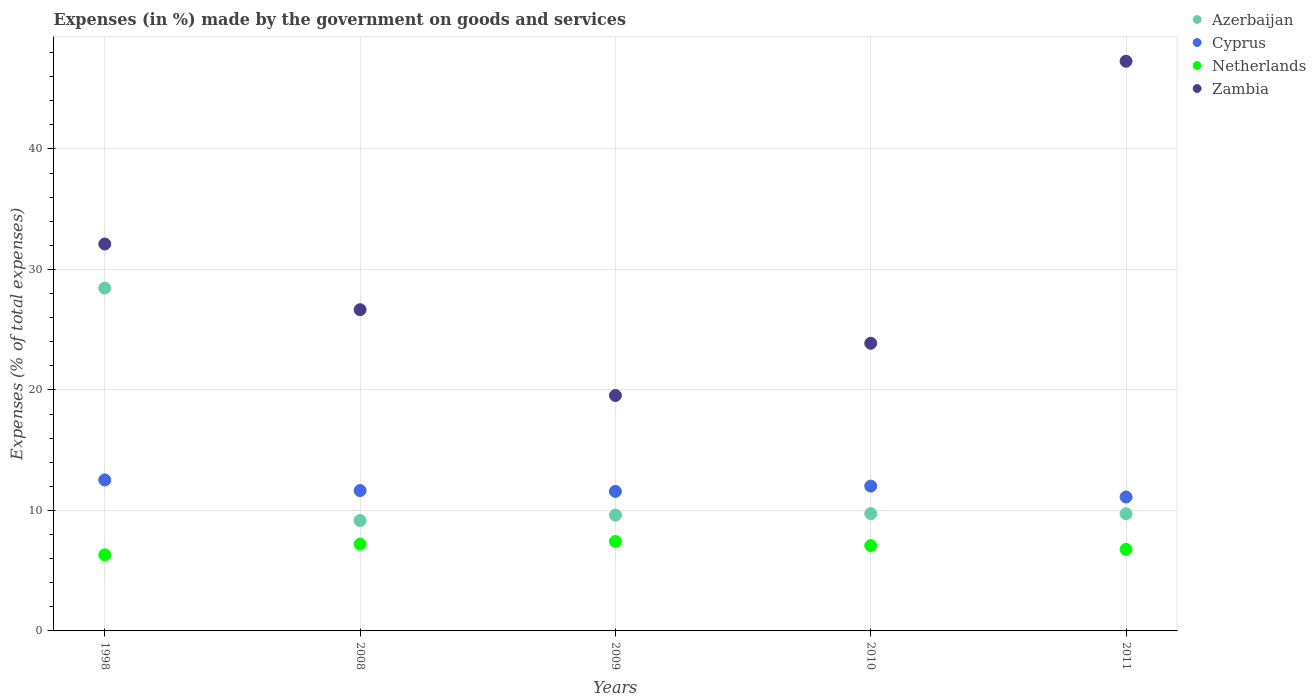Is the number of dotlines equal to the number of legend labels?
Ensure brevity in your answer.  Yes. What is the percentage of expenses made by the government on goods and services in Azerbaijan in 2011?
Keep it short and to the point. 9.73. Across all years, what is the maximum percentage of expenses made by the government on goods and services in Netherlands?
Ensure brevity in your answer.  7.43. Across all years, what is the minimum percentage of expenses made by the government on goods and services in Azerbaijan?
Provide a short and direct response. 9.16. In which year was the percentage of expenses made by the government on goods and services in Cyprus minimum?
Your response must be concise. 2011. What is the total percentage of expenses made by the government on goods and services in Azerbaijan in the graph?
Provide a succinct answer. 66.69. What is the difference between the percentage of expenses made by the government on goods and services in Azerbaijan in 1998 and that in 2009?
Your answer should be compact. 18.84. What is the difference between the percentage of expenses made by the government on goods and services in Zambia in 1998 and the percentage of expenses made by the government on goods and services in Azerbaijan in 2008?
Provide a short and direct response. 22.95. What is the average percentage of expenses made by the government on goods and services in Netherlands per year?
Your answer should be very brief. 6.96. In the year 2009, what is the difference between the percentage of expenses made by the government on goods and services in Azerbaijan and percentage of expenses made by the government on goods and services in Cyprus?
Provide a short and direct response. -1.97. In how many years, is the percentage of expenses made by the government on goods and services in Netherlands greater than 4 %?
Your response must be concise. 5. What is the ratio of the percentage of expenses made by the government on goods and services in Cyprus in 2009 to that in 2010?
Give a very brief answer. 0.96. Is the percentage of expenses made by the government on goods and services in Cyprus in 1998 less than that in 2009?
Offer a very short reply. No. Is the difference between the percentage of expenses made by the government on goods and services in Azerbaijan in 2009 and 2011 greater than the difference between the percentage of expenses made by the government on goods and services in Cyprus in 2009 and 2011?
Your response must be concise. No. What is the difference between the highest and the second highest percentage of expenses made by the government on goods and services in Netherlands?
Your response must be concise. 0.23. What is the difference between the highest and the lowest percentage of expenses made by the government on goods and services in Netherlands?
Offer a terse response. 1.11. In how many years, is the percentage of expenses made by the government on goods and services in Netherlands greater than the average percentage of expenses made by the government on goods and services in Netherlands taken over all years?
Your answer should be very brief. 3. Is it the case that in every year, the sum of the percentage of expenses made by the government on goods and services in Zambia and percentage of expenses made by the government on goods and services in Netherlands  is greater than the sum of percentage of expenses made by the government on goods and services in Cyprus and percentage of expenses made by the government on goods and services in Azerbaijan?
Offer a terse response. Yes. Does the percentage of expenses made by the government on goods and services in Azerbaijan monotonically increase over the years?
Provide a succinct answer. No. Is the percentage of expenses made by the government on goods and services in Zambia strictly greater than the percentage of expenses made by the government on goods and services in Netherlands over the years?
Make the answer very short. Yes. Is the percentage of expenses made by the government on goods and services in Cyprus strictly less than the percentage of expenses made by the government on goods and services in Netherlands over the years?
Ensure brevity in your answer.  No. How many years are there in the graph?
Provide a short and direct response. 5. Are the values on the major ticks of Y-axis written in scientific E-notation?
Make the answer very short. No. Does the graph contain any zero values?
Make the answer very short. No. Does the graph contain grids?
Offer a terse response. Yes. How are the legend labels stacked?
Your answer should be very brief. Vertical. What is the title of the graph?
Give a very brief answer. Expenses (in %) made by the government on goods and services. Does "Myanmar" appear as one of the legend labels in the graph?
Provide a succinct answer. No. What is the label or title of the Y-axis?
Provide a succinct answer. Expenses (% of total expenses). What is the Expenses (% of total expenses) in Azerbaijan in 1998?
Make the answer very short. 28.45. What is the Expenses (% of total expenses) in Cyprus in 1998?
Your answer should be very brief. 12.53. What is the Expenses (% of total expenses) in Netherlands in 1998?
Your response must be concise. 6.32. What is the Expenses (% of total expenses) of Zambia in 1998?
Your answer should be compact. 32.11. What is the Expenses (% of total expenses) in Azerbaijan in 2008?
Your answer should be compact. 9.16. What is the Expenses (% of total expenses) in Cyprus in 2008?
Make the answer very short. 11.65. What is the Expenses (% of total expenses) in Netherlands in 2008?
Ensure brevity in your answer.  7.2. What is the Expenses (% of total expenses) in Zambia in 2008?
Your response must be concise. 26.66. What is the Expenses (% of total expenses) of Azerbaijan in 2009?
Your response must be concise. 9.61. What is the Expenses (% of total expenses) of Cyprus in 2009?
Make the answer very short. 11.58. What is the Expenses (% of total expenses) of Netherlands in 2009?
Your answer should be very brief. 7.43. What is the Expenses (% of total expenses) in Zambia in 2009?
Provide a succinct answer. 19.54. What is the Expenses (% of total expenses) in Azerbaijan in 2010?
Keep it short and to the point. 9.74. What is the Expenses (% of total expenses) of Cyprus in 2010?
Ensure brevity in your answer.  12.02. What is the Expenses (% of total expenses) of Netherlands in 2010?
Your response must be concise. 7.08. What is the Expenses (% of total expenses) in Zambia in 2010?
Provide a short and direct response. 23.87. What is the Expenses (% of total expenses) of Azerbaijan in 2011?
Provide a succinct answer. 9.73. What is the Expenses (% of total expenses) of Cyprus in 2011?
Give a very brief answer. 11.11. What is the Expenses (% of total expenses) in Netherlands in 2011?
Give a very brief answer. 6.77. What is the Expenses (% of total expenses) in Zambia in 2011?
Make the answer very short. 47.28. Across all years, what is the maximum Expenses (% of total expenses) of Azerbaijan?
Keep it short and to the point. 28.45. Across all years, what is the maximum Expenses (% of total expenses) in Cyprus?
Provide a succinct answer. 12.53. Across all years, what is the maximum Expenses (% of total expenses) of Netherlands?
Offer a very short reply. 7.43. Across all years, what is the maximum Expenses (% of total expenses) in Zambia?
Offer a very short reply. 47.28. Across all years, what is the minimum Expenses (% of total expenses) in Azerbaijan?
Offer a very short reply. 9.16. Across all years, what is the minimum Expenses (% of total expenses) in Cyprus?
Your answer should be very brief. 11.11. Across all years, what is the minimum Expenses (% of total expenses) of Netherlands?
Offer a very short reply. 6.32. Across all years, what is the minimum Expenses (% of total expenses) of Zambia?
Provide a succinct answer. 19.54. What is the total Expenses (% of total expenses) of Azerbaijan in the graph?
Provide a succinct answer. 66.69. What is the total Expenses (% of total expenses) in Cyprus in the graph?
Your answer should be compact. 58.89. What is the total Expenses (% of total expenses) of Netherlands in the graph?
Give a very brief answer. 34.79. What is the total Expenses (% of total expenses) of Zambia in the graph?
Ensure brevity in your answer.  149.46. What is the difference between the Expenses (% of total expenses) of Azerbaijan in 1998 and that in 2008?
Keep it short and to the point. 19.29. What is the difference between the Expenses (% of total expenses) in Cyprus in 1998 and that in 2008?
Give a very brief answer. 0.88. What is the difference between the Expenses (% of total expenses) of Netherlands in 1998 and that in 2008?
Your answer should be compact. -0.88. What is the difference between the Expenses (% of total expenses) of Zambia in 1998 and that in 2008?
Make the answer very short. 5.45. What is the difference between the Expenses (% of total expenses) in Azerbaijan in 1998 and that in 2009?
Make the answer very short. 18.84. What is the difference between the Expenses (% of total expenses) of Cyprus in 1998 and that in 2009?
Provide a short and direct response. 0.95. What is the difference between the Expenses (% of total expenses) in Netherlands in 1998 and that in 2009?
Offer a very short reply. -1.11. What is the difference between the Expenses (% of total expenses) of Zambia in 1998 and that in 2009?
Keep it short and to the point. 12.57. What is the difference between the Expenses (% of total expenses) of Azerbaijan in 1998 and that in 2010?
Ensure brevity in your answer.  18.71. What is the difference between the Expenses (% of total expenses) in Cyprus in 1998 and that in 2010?
Ensure brevity in your answer.  0.51. What is the difference between the Expenses (% of total expenses) of Netherlands in 1998 and that in 2010?
Your answer should be very brief. -0.77. What is the difference between the Expenses (% of total expenses) of Zambia in 1998 and that in 2010?
Offer a terse response. 8.24. What is the difference between the Expenses (% of total expenses) in Azerbaijan in 1998 and that in 2011?
Ensure brevity in your answer.  18.72. What is the difference between the Expenses (% of total expenses) of Cyprus in 1998 and that in 2011?
Offer a very short reply. 1.42. What is the difference between the Expenses (% of total expenses) in Netherlands in 1998 and that in 2011?
Your answer should be very brief. -0.45. What is the difference between the Expenses (% of total expenses) in Zambia in 1998 and that in 2011?
Your response must be concise. -15.17. What is the difference between the Expenses (% of total expenses) in Azerbaijan in 2008 and that in 2009?
Provide a short and direct response. -0.45. What is the difference between the Expenses (% of total expenses) of Cyprus in 2008 and that in 2009?
Offer a terse response. 0.07. What is the difference between the Expenses (% of total expenses) of Netherlands in 2008 and that in 2009?
Ensure brevity in your answer.  -0.23. What is the difference between the Expenses (% of total expenses) in Zambia in 2008 and that in 2009?
Your answer should be compact. 7.12. What is the difference between the Expenses (% of total expenses) of Azerbaijan in 2008 and that in 2010?
Make the answer very short. -0.58. What is the difference between the Expenses (% of total expenses) of Cyprus in 2008 and that in 2010?
Keep it short and to the point. -0.37. What is the difference between the Expenses (% of total expenses) of Netherlands in 2008 and that in 2010?
Keep it short and to the point. 0.12. What is the difference between the Expenses (% of total expenses) in Zambia in 2008 and that in 2010?
Your response must be concise. 2.79. What is the difference between the Expenses (% of total expenses) in Azerbaijan in 2008 and that in 2011?
Your answer should be very brief. -0.57. What is the difference between the Expenses (% of total expenses) in Cyprus in 2008 and that in 2011?
Make the answer very short. 0.53. What is the difference between the Expenses (% of total expenses) in Netherlands in 2008 and that in 2011?
Your answer should be compact. 0.43. What is the difference between the Expenses (% of total expenses) of Zambia in 2008 and that in 2011?
Ensure brevity in your answer.  -20.62. What is the difference between the Expenses (% of total expenses) of Azerbaijan in 2009 and that in 2010?
Provide a succinct answer. -0.13. What is the difference between the Expenses (% of total expenses) of Cyprus in 2009 and that in 2010?
Ensure brevity in your answer.  -0.44. What is the difference between the Expenses (% of total expenses) of Netherlands in 2009 and that in 2010?
Your answer should be compact. 0.34. What is the difference between the Expenses (% of total expenses) of Zambia in 2009 and that in 2010?
Make the answer very short. -4.34. What is the difference between the Expenses (% of total expenses) in Azerbaijan in 2009 and that in 2011?
Provide a short and direct response. -0.11. What is the difference between the Expenses (% of total expenses) in Cyprus in 2009 and that in 2011?
Offer a terse response. 0.47. What is the difference between the Expenses (% of total expenses) of Netherlands in 2009 and that in 2011?
Your response must be concise. 0.66. What is the difference between the Expenses (% of total expenses) in Zambia in 2009 and that in 2011?
Your answer should be compact. -27.74. What is the difference between the Expenses (% of total expenses) in Azerbaijan in 2010 and that in 2011?
Offer a very short reply. 0.01. What is the difference between the Expenses (% of total expenses) of Cyprus in 2010 and that in 2011?
Provide a succinct answer. 0.91. What is the difference between the Expenses (% of total expenses) in Netherlands in 2010 and that in 2011?
Provide a short and direct response. 0.31. What is the difference between the Expenses (% of total expenses) of Zambia in 2010 and that in 2011?
Make the answer very short. -23.41. What is the difference between the Expenses (% of total expenses) in Azerbaijan in 1998 and the Expenses (% of total expenses) in Cyprus in 2008?
Your answer should be very brief. 16.8. What is the difference between the Expenses (% of total expenses) in Azerbaijan in 1998 and the Expenses (% of total expenses) in Netherlands in 2008?
Keep it short and to the point. 21.25. What is the difference between the Expenses (% of total expenses) in Azerbaijan in 1998 and the Expenses (% of total expenses) in Zambia in 2008?
Ensure brevity in your answer.  1.79. What is the difference between the Expenses (% of total expenses) in Cyprus in 1998 and the Expenses (% of total expenses) in Netherlands in 2008?
Make the answer very short. 5.33. What is the difference between the Expenses (% of total expenses) in Cyprus in 1998 and the Expenses (% of total expenses) in Zambia in 2008?
Provide a succinct answer. -14.13. What is the difference between the Expenses (% of total expenses) of Netherlands in 1998 and the Expenses (% of total expenses) of Zambia in 2008?
Ensure brevity in your answer.  -20.34. What is the difference between the Expenses (% of total expenses) in Azerbaijan in 1998 and the Expenses (% of total expenses) in Cyprus in 2009?
Offer a very short reply. 16.87. What is the difference between the Expenses (% of total expenses) of Azerbaijan in 1998 and the Expenses (% of total expenses) of Netherlands in 2009?
Your answer should be very brief. 21.02. What is the difference between the Expenses (% of total expenses) in Azerbaijan in 1998 and the Expenses (% of total expenses) in Zambia in 2009?
Offer a very short reply. 8.91. What is the difference between the Expenses (% of total expenses) in Cyprus in 1998 and the Expenses (% of total expenses) in Netherlands in 2009?
Provide a succinct answer. 5.1. What is the difference between the Expenses (% of total expenses) in Cyprus in 1998 and the Expenses (% of total expenses) in Zambia in 2009?
Make the answer very short. -7.01. What is the difference between the Expenses (% of total expenses) in Netherlands in 1998 and the Expenses (% of total expenses) in Zambia in 2009?
Your answer should be compact. -13.22. What is the difference between the Expenses (% of total expenses) in Azerbaijan in 1998 and the Expenses (% of total expenses) in Cyprus in 2010?
Make the answer very short. 16.43. What is the difference between the Expenses (% of total expenses) in Azerbaijan in 1998 and the Expenses (% of total expenses) in Netherlands in 2010?
Your response must be concise. 21.37. What is the difference between the Expenses (% of total expenses) of Azerbaijan in 1998 and the Expenses (% of total expenses) of Zambia in 2010?
Your response must be concise. 4.58. What is the difference between the Expenses (% of total expenses) in Cyprus in 1998 and the Expenses (% of total expenses) in Netherlands in 2010?
Your answer should be compact. 5.45. What is the difference between the Expenses (% of total expenses) of Cyprus in 1998 and the Expenses (% of total expenses) of Zambia in 2010?
Provide a succinct answer. -11.34. What is the difference between the Expenses (% of total expenses) in Netherlands in 1998 and the Expenses (% of total expenses) in Zambia in 2010?
Give a very brief answer. -17.56. What is the difference between the Expenses (% of total expenses) of Azerbaijan in 1998 and the Expenses (% of total expenses) of Cyprus in 2011?
Keep it short and to the point. 17.33. What is the difference between the Expenses (% of total expenses) in Azerbaijan in 1998 and the Expenses (% of total expenses) in Netherlands in 2011?
Provide a succinct answer. 21.68. What is the difference between the Expenses (% of total expenses) in Azerbaijan in 1998 and the Expenses (% of total expenses) in Zambia in 2011?
Offer a very short reply. -18.83. What is the difference between the Expenses (% of total expenses) of Cyprus in 1998 and the Expenses (% of total expenses) of Netherlands in 2011?
Ensure brevity in your answer.  5.76. What is the difference between the Expenses (% of total expenses) of Cyprus in 1998 and the Expenses (% of total expenses) of Zambia in 2011?
Provide a succinct answer. -34.75. What is the difference between the Expenses (% of total expenses) of Netherlands in 1998 and the Expenses (% of total expenses) of Zambia in 2011?
Make the answer very short. -40.96. What is the difference between the Expenses (% of total expenses) of Azerbaijan in 2008 and the Expenses (% of total expenses) of Cyprus in 2009?
Make the answer very short. -2.42. What is the difference between the Expenses (% of total expenses) of Azerbaijan in 2008 and the Expenses (% of total expenses) of Netherlands in 2009?
Provide a succinct answer. 1.73. What is the difference between the Expenses (% of total expenses) of Azerbaijan in 2008 and the Expenses (% of total expenses) of Zambia in 2009?
Your answer should be very brief. -10.38. What is the difference between the Expenses (% of total expenses) in Cyprus in 2008 and the Expenses (% of total expenses) in Netherlands in 2009?
Provide a short and direct response. 4.22. What is the difference between the Expenses (% of total expenses) of Cyprus in 2008 and the Expenses (% of total expenses) of Zambia in 2009?
Give a very brief answer. -7.89. What is the difference between the Expenses (% of total expenses) of Netherlands in 2008 and the Expenses (% of total expenses) of Zambia in 2009?
Offer a terse response. -12.34. What is the difference between the Expenses (% of total expenses) in Azerbaijan in 2008 and the Expenses (% of total expenses) in Cyprus in 2010?
Your response must be concise. -2.86. What is the difference between the Expenses (% of total expenses) of Azerbaijan in 2008 and the Expenses (% of total expenses) of Netherlands in 2010?
Provide a short and direct response. 2.08. What is the difference between the Expenses (% of total expenses) in Azerbaijan in 2008 and the Expenses (% of total expenses) in Zambia in 2010?
Offer a very short reply. -14.71. What is the difference between the Expenses (% of total expenses) of Cyprus in 2008 and the Expenses (% of total expenses) of Netherlands in 2010?
Your answer should be very brief. 4.57. What is the difference between the Expenses (% of total expenses) in Cyprus in 2008 and the Expenses (% of total expenses) in Zambia in 2010?
Give a very brief answer. -12.23. What is the difference between the Expenses (% of total expenses) in Netherlands in 2008 and the Expenses (% of total expenses) in Zambia in 2010?
Offer a terse response. -16.67. What is the difference between the Expenses (% of total expenses) in Azerbaijan in 2008 and the Expenses (% of total expenses) in Cyprus in 2011?
Provide a succinct answer. -1.95. What is the difference between the Expenses (% of total expenses) of Azerbaijan in 2008 and the Expenses (% of total expenses) of Netherlands in 2011?
Provide a succinct answer. 2.39. What is the difference between the Expenses (% of total expenses) of Azerbaijan in 2008 and the Expenses (% of total expenses) of Zambia in 2011?
Your answer should be compact. -38.12. What is the difference between the Expenses (% of total expenses) of Cyprus in 2008 and the Expenses (% of total expenses) of Netherlands in 2011?
Give a very brief answer. 4.88. What is the difference between the Expenses (% of total expenses) of Cyprus in 2008 and the Expenses (% of total expenses) of Zambia in 2011?
Provide a succinct answer. -35.63. What is the difference between the Expenses (% of total expenses) in Netherlands in 2008 and the Expenses (% of total expenses) in Zambia in 2011?
Your answer should be compact. -40.08. What is the difference between the Expenses (% of total expenses) in Azerbaijan in 2009 and the Expenses (% of total expenses) in Cyprus in 2010?
Your answer should be compact. -2.41. What is the difference between the Expenses (% of total expenses) in Azerbaijan in 2009 and the Expenses (% of total expenses) in Netherlands in 2010?
Offer a very short reply. 2.53. What is the difference between the Expenses (% of total expenses) of Azerbaijan in 2009 and the Expenses (% of total expenses) of Zambia in 2010?
Keep it short and to the point. -14.26. What is the difference between the Expenses (% of total expenses) of Cyprus in 2009 and the Expenses (% of total expenses) of Netherlands in 2010?
Provide a succinct answer. 4.5. What is the difference between the Expenses (% of total expenses) of Cyprus in 2009 and the Expenses (% of total expenses) of Zambia in 2010?
Offer a terse response. -12.29. What is the difference between the Expenses (% of total expenses) in Netherlands in 2009 and the Expenses (% of total expenses) in Zambia in 2010?
Give a very brief answer. -16.45. What is the difference between the Expenses (% of total expenses) in Azerbaijan in 2009 and the Expenses (% of total expenses) in Cyprus in 2011?
Make the answer very short. -1.5. What is the difference between the Expenses (% of total expenses) in Azerbaijan in 2009 and the Expenses (% of total expenses) in Netherlands in 2011?
Ensure brevity in your answer.  2.84. What is the difference between the Expenses (% of total expenses) in Azerbaijan in 2009 and the Expenses (% of total expenses) in Zambia in 2011?
Offer a terse response. -37.67. What is the difference between the Expenses (% of total expenses) in Cyprus in 2009 and the Expenses (% of total expenses) in Netherlands in 2011?
Your answer should be very brief. 4.81. What is the difference between the Expenses (% of total expenses) of Cyprus in 2009 and the Expenses (% of total expenses) of Zambia in 2011?
Ensure brevity in your answer.  -35.7. What is the difference between the Expenses (% of total expenses) of Netherlands in 2009 and the Expenses (% of total expenses) of Zambia in 2011?
Ensure brevity in your answer.  -39.85. What is the difference between the Expenses (% of total expenses) in Azerbaijan in 2010 and the Expenses (% of total expenses) in Cyprus in 2011?
Provide a short and direct response. -1.38. What is the difference between the Expenses (% of total expenses) of Azerbaijan in 2010 and the Expenses (% of total expenses) of Netherlands in 2011?
Offer a very short reply. 2.97. What is the difference between the Expenses (% of total expenses) in Azerbaijan in 2010 and the Expenses (% of total expenses) in Zambia in 2011?
Provide a succinct answer. -37.54. What is the difference between the Expenses (% of total expenses) in Cyprus in 2010 and the Expenses (% of total expenses) in Netherlands in 2011?
Your response must be concise. 5.25. What is the difference between the Expenses (% of total expenses) in Cyprus in 2010 and the Expenses (% of total expenses) in Zambia in 2011?
Keep it short and to the point. -35.26. What is the difference between the Expenses (% of total expenses) in Netherlands in 2010 and the Expenses (% of total expenses) in Zambia in 2011?
Keep it short and to the point. -40.2. What is the average Expenses (% of total expenses) in Azerbaijan per year?
Your answer should be compact. 13.34. What is the average Expenses (% of total expenses) in Cyprus per year?
Your response must be concise. 11.78. What is the average Expenses (% of total expenses) in Netherlands per year?
Provide a short and direct response. 6.96. What is the average Expenses (% of total expenses) of Zambia per year?
Keep it short and to the point. 29.89. In the year 1998, what is the difference between the Expenses (% of total expenses) of Azerbaijan and Expenses (% of total expenses) of Cyprus?
Ensure brevity in your answer.  15.92. In the year 1998, what is the difference between the Expenses (% of total expenses) of Azerbaijan and Expenses (% of total expenses) of Netherlands?
Offer a very short reply. 22.13. In the year 1998, what is the difference between the Expenses (% of total expenses) in Azerbaijan and Expenses (% of total expenses) in Zambia?
Give a very brief answer. -3.66. In the year 1998, what is the difference between the Expenses (% of total expenses) in Cyprus and Expenses (% of total expenses) in Netherlands?
Provide a short and direct response. 6.21. In the year 1998, what is the difference between the Expenses (% of total expenses) of Cyprus and Expenses (% of total expenses) of Zambia?
Your answer should be very brief. -19.58. In the year 1998, what is the difference between the Expenses (% of total expenses) of Netherlands and Expenses (% of total expenses) of Zambia?
Your response must be concise. -25.79. In the year 2008, what is the difference between the Expenses (% of total expenses) in Azerbaijan and Expenses (% of total expenses) in Cyprus?
Offer a terse response. -2.49. In the year 2008, what is the difference between the Expenses (% of total expenses) in Azerbaijan and Expenses (% of total expenses) in Netherlands?
Give a very brief answer. 1.96. In the year 2008, what is the difference between the Expenses (% of total expenses) of Azerbaijan and Expenses (% of total expenses) of Zambia?
Your response must be concise. -17.5. In the year 2008, what is the difference between the Expenses (% of total expenses) in Cyprus and Expenses (% of total expenses) in Netherlands?
Ensure brevity in your answer.  4.45. In the year 2008, what is the difference between the Expenses (% of total expenses) in Cyprus and Expenses (% of total expenses) in Zambia?
Give a very brief answer. -15.01. In the year 2008, what is the difference between the Expenses (% of total expenses) in Netherlands and Expenses (% of total expenses) in Zambia?
Your answer should be very brief. -19.46. In the year 2009, what is the difference between the Expenses (% of total expenses) in Azerbaijan and Expenses (% of total expenses) in Cyprus?
Your answer should be compact. -1.97. In the year 2009, what is the difference between the Expenses (% of total expenses) in Azerbaijan and Expenses (% of total expenses) in Netherlands?
Offer a terse response. 2.19. In the year 2009, what is the difference between the Expenses (% of total expenses) of Azerbaijan and Expenses (% of total expenses) of Zambia?
Provide a succinct answer. -9.93. In the year 2009, what is the difference between the Expenses (% of total expenses) in Cyprus and Expenses (% of total expenses) in Netherlands?
Provide a short and direct response. 4.15. In the year 2009, what is the difference between the Expenses (% of total expenses) of Cyprus and Expenses (% of total expenses) of Zambia?
Ensure brevity in your answer.  -7.96. In the year 2009, what is the difference between the Expenses (% of total expenses) of Netherlands and Expenses (% of total expenses) of Zambia?
Offer a terse response. -12.11. In the year 2010, what is the difference between the Expenses (% of total expenses) in Azerbaijan and Expenses (% of total expenses) in Cyprus?
Your response must be concise. -2.28. In the year 2010, what is the difference between the Expenses (% of total expenses) in Azerbaijan and Expenses (% of total expenses) in Netherlands?
Make the answer very short. 2.66. In the year 2010, what is the difference between the Expenses (% of total expenses) in Azerbaijan and Expenses (% of total expenses) in Zambia?
Keep it short and to the point. -14.13. In the year 2010, what is the difference between the Expenses (% of total expenses) of Cyprus and Expenses (% of total expenses) of Netherlands?
Offer a very short reply. 4.94. In the year 2010, what is the difference between the Expenses (% of total expenses) in Cyprus and Expenses (% of total expenses) in Zambia?
Provide a short and direct response. -11.85. In the year 2010, what is the difference between the Expenses (% of total expenses) of Netherlands and Expenses (% of total expenses) of Zambia?
Provide a succinct answer. -16.79. In the year 2011, what is the difference between the Expenses (% of total expenses) in Azerbaijan and Expenses (% of total expenses) in Cyprus?
Your answer should be very brief. -1.39. In the year 2011, what is the difference between the Expenses (% of total expenses) in Azerbaijan and Expenses (% of total expenses) in Netherlands?
Provide a succinct answer. 2.96. In the year 2011, what is the difference between the Expenses (% of total expenses) in Azerbaijan and Expenses (% of total expenses) in Zambia?
Your response must be concise. -37.55. In the year 2011, what is the difference between the Expenses (% of total expenses) in Cyprus and Expenses (% of total expenses) in Netherlands?
Provide a succinct answer. 4.34. In the year 2011, what is the difference between the Expenses (% of total expenses) of Cyprus and Expenses (% of total expenses) of Zambia?
Provide a short and direct response. -36.16. In the year 2011, what is the difference between the Expenses (% of total expenses) of Netherlands and Expenses (% of total expenses) of Zambia?
Provide a short and direct response. -40.51. What is the ratio of the Expenses (% of total expenses) in Azerbaijan in 1998 to that in 2008?
Ensure brevity in your answer.  3.11. What is the ratio of the Expenses (% of total expenses) in Cyprus in 1998 to that in 2008?
Make the answer very short. 1.08. What is the ratio of the Expenses (% of total expenses) of Netherlands in 1998 to that in 2008?
Your response must be concise. 0.88. What is the ratio of the Expenses (% of total expenses) of Zambia in 1998 to that in 2008?
Offer a terse response. 1.2. What is the ratio of the Expenses (% of total expenses) of Azerbaijan in 1998 to that in 2009?
Your answer should be very brief. 2.96. What is the ratio of the Expenses (% of total expenses) of Cyprus in 1998 to that in 2009?
Your response must be concise. 1.08. What is the ratio of the Expenses (% of total expenses) in Netherlands in 1998 to that in 2009?
Your answer should be very brief. 0.85. What is the ratio of the Expenses (% of total expenses) in Zambia in 1998 to that in 2009?
Make the answer very short. 1.64. What is the ratio of the Expenses (% of total expenses) in Azerbaijan in 1998 to that in 2010?
Offer a very short reply. 2.92. What is the ratio of the Expenses (% of total expenses) of Cyprus in 1998 to that in 2010?
Your answer should be very brief. 1.04. What is the ratio of the Expenses (% of total expenses) of Netherlands in 1998 to that in 2010?
Provide a short and direct response. 0.89. What is the ratio of the Expenses (% of total expenses) in Zambia in 1998 to that in 2010?
Provide a succinct answer. 1.34. What is the ratio of the Expenses (% of total expenses) in Azerbaijan in 1998 to that in 2011?
Provide a short and direct response. 2.92. What is the ratio of the Expenses (% of total expenses) in Cyprus in 1998 to that in 2011?
Provide a short and direct response. 1.13. What is the ratio of the Expenses (% of total expenses) of Netherlands in 1998 to that in 2011?
Make the answer very short. 0.93. What is the ratio of the Expenses (% of total expenses) of Zambia in 1998 to that in 2011?
Your answer should be very brief. 0.68. What is the ratio of the Expenses (% of total expenses) in Azerbaijan in 2008 to that in 2009?
Offer a very short reply. 0.95. What is the ratio of the Expenses (% of total expenses) of Cyprus in 2008 to that in 2009?
Provide a succinct answer. 1.01. What is the ratio of the Expenses (% of total expenses) of Netherlands in 2008 to that in 2009?
Ensure brevity in your answer.  0.97. What is the ratio of the Expenses (% of total expenses) in Zambia in 2008 to that in 2009?
Keep it short and to the point. 1.36. What is the ratio of the Expenses (% of total expenses) of Azerbaijan in 2008 to that in 2010?
Your answer should be compact. 0.94. What is the ratio of the Expenses (% of total expenses) of Cyprus in 2008 to that in 2010?
Offer a very short reply. 0.97. What is the ratio of the Expenses (% of total expenses) in Netherlands in 2008 to that in 2010?
Provide a short and direct response. 1.02. What is the ratio of the Expenses (% of total expenses) in Zambia in 2008 to that in 2010?
Provide a succinct answer. 1.12. What is the ratio of the Expenses (% of total expenses) in Azerbaijan in 2008 to that in 2011?
Ensure brevity in your answer.  0.94. What is the ratio of the Expenses (% of total expenses) in Cyprus in 2008 to that in 2011?
Give a very brief answer. 1.05. What is the ratio of the Expenses (% of total expenses) of Netherlands in 2008 to that in 2011?
Offer a very short reply. 1.06. What is the ratio of the Expenses (% of total expenses) in Zambia in 2008 to that in 2011?
Your answer should be compact. 0.56. What is the ratio of the Expenses (% of total expenses) in Azerbaijan in 2009 to that in 2010?
Keep it short and to the point. 0.99. What is the ratio of the Expenses (% of total expenses) in Cyprus in 2009 to that in 2010?
Provide a short and direct response. 0.96. What is the ratio of the Expenses (% of total expenses) of Netherlands in 2009 to that in 2010?
Ensure brevity in your answer.  1.05. What is the ratio of the Expenses (% of total expenses) of Zambia in 2009 to that in 2010?
Provide a succinct answer. 0.82. What is the ratio of the Expenses (% of total expenses) of Azerbaijan in 2009 to that in 2011?
Keep it short and to the point. 0.99. What is the ratio of the Expenses (% of total expenses) in Cyprus in 2009 to that in 2011?
Your answer should be very brief. 1.04. What is the ratio of the Expenses (% of total expenses) in Netherlands in 2009 to that in 2011?
Your response must be concise. 1.1. What is the ratio of the Expenses (% of total expenses) of Zambia in 2009 to that in 2011?
Make the answer very short. 0.41. What is the ratio of the Expenses (% of total expenses) of Azerbaijan in 2010 to that in 2011?
Provide a succinct answer. 1. What is the ratio of the Expenses (% of total expenses) in Cyprus in 2010 to that in 2011?
Provide a short and direct response. 1.08. What is the ratio of the Expenses (% of total expenses) of Netherlands in 2010 to that in 2011?
Keep it short and to the point. 1.05. What is the ratio of the Expenses (% of total expenses) of Zambia in 2010 to that in 2011?
Your answer should be very brief. 0.5. What is the difference between the highest and the second highest Expenses (% of total expenses) in Azerbaijan?
Your answer should be compact. 18.71. What is the difference between the highest and the second highest Expenses (% of total expenses) in Cyprus?
Your answer should be compact. 0.51. What is the difference between the highest and the second highest Expenses (% of total expenses) in Netherlands?
Provide a succinct answer. 0.23. What is the difference between the highest and the second highest Expenses (% of total expenses) of Zambia?
Offer a terse response. 15.17. What is the difference between the highest and the lowest Expenses (% of total expenses) of Azerbaijan?
Provide a short and direct response. 19.29. What is the difference between the highest and the lowest Expenses (% of total expenses) of Cyprus?
Give a very brief answer. 1.42. What is the difference between the highest and the lowest Expenses (% of total expenses) in Netherlands?
Provide a short and direct response. 1.11. What is the difference between the highest and the lowest Expenses (% of total expenses) in Zambia?
Ensure brevity in your answer.  27.74. 